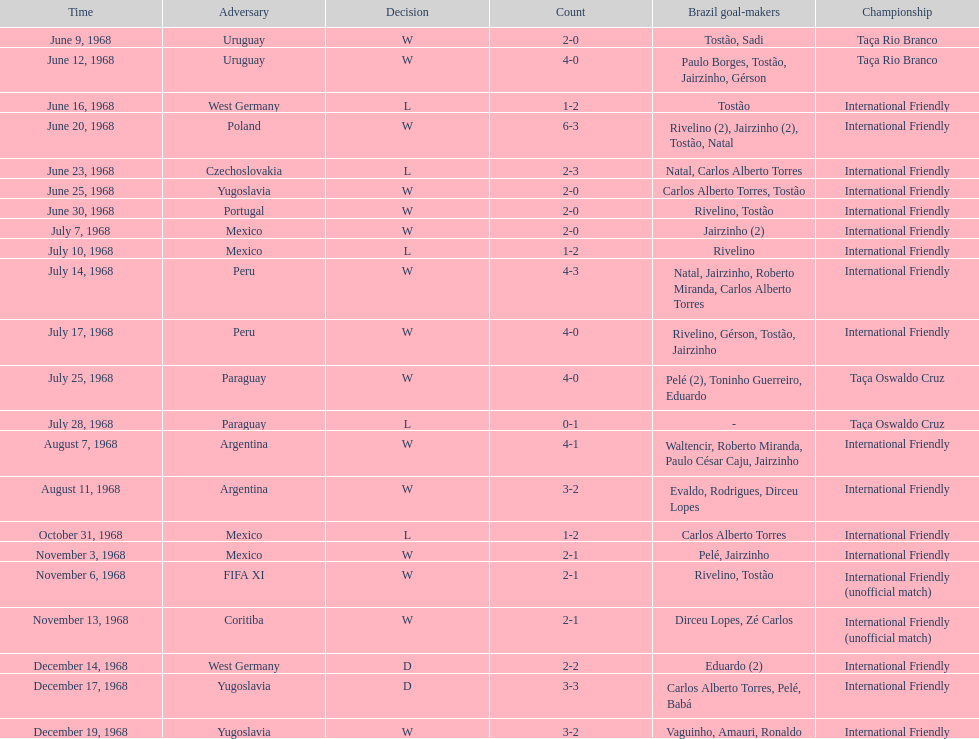Name the first competition ever played by brazil. Taça Rio Branco. 